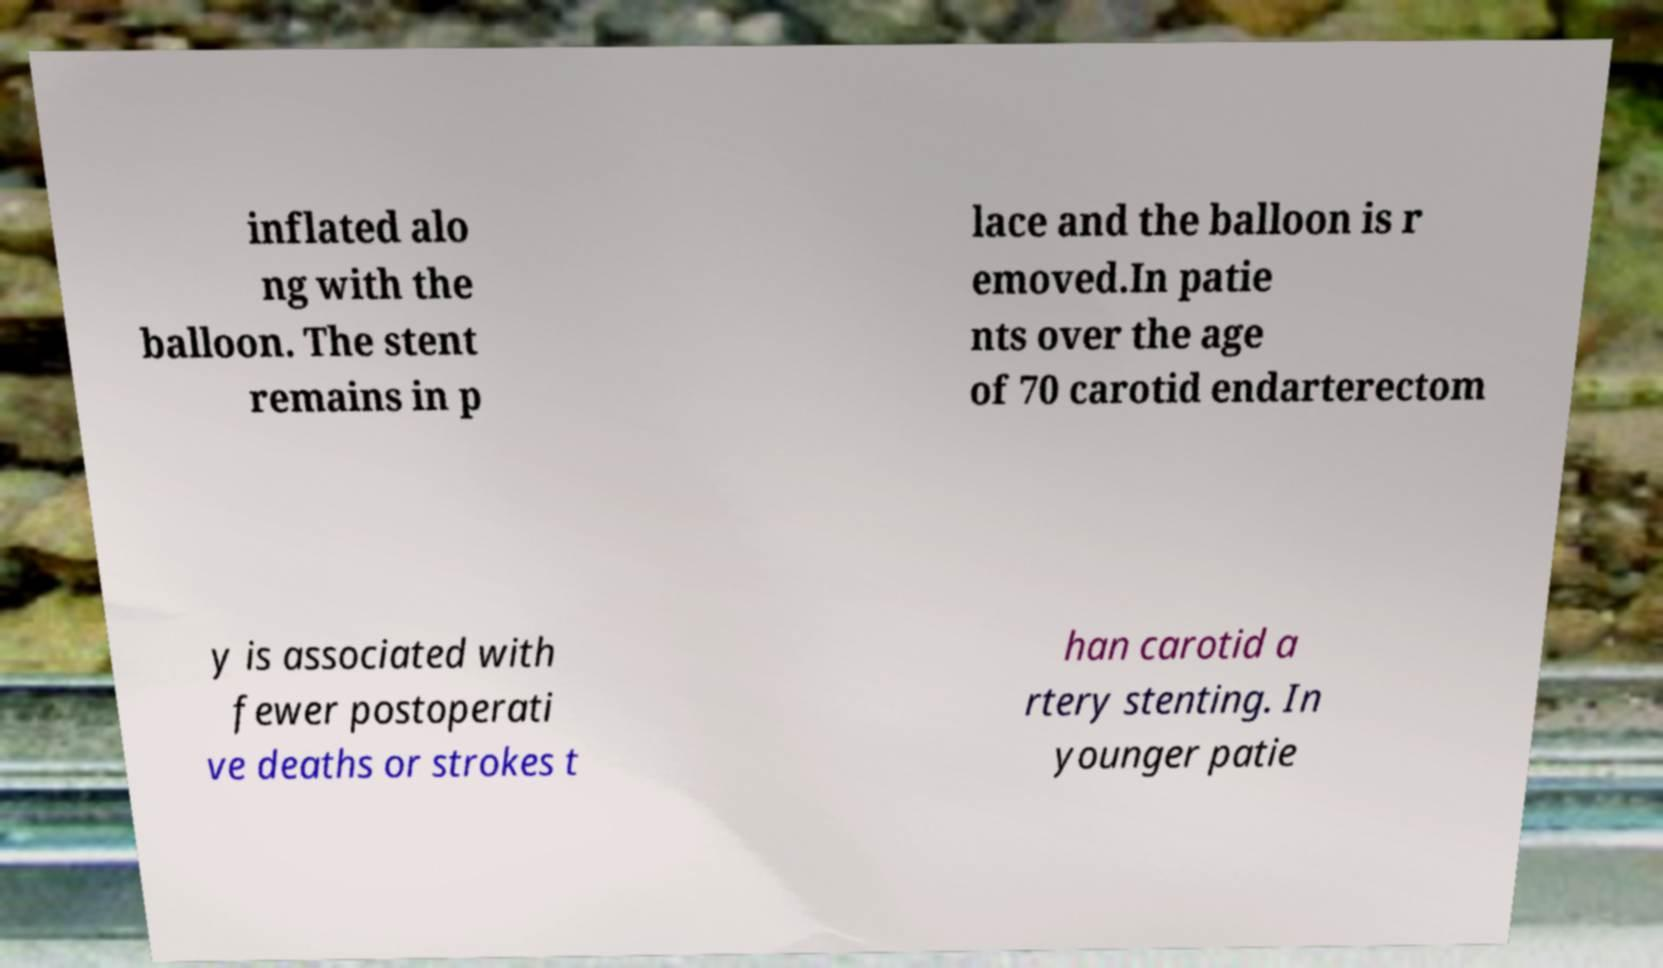There's text embedded in this image that I need extracted. Can you transcribe it verbatim? inflated alo ng with the balloon. The stent remains in p lace and the balloon is r emoved.In patie nts over the age of 70 carotid endarterectom y is associated with fewer postoperati ve deaths or strokes t han carotid a rtery stenting. In younger patie 